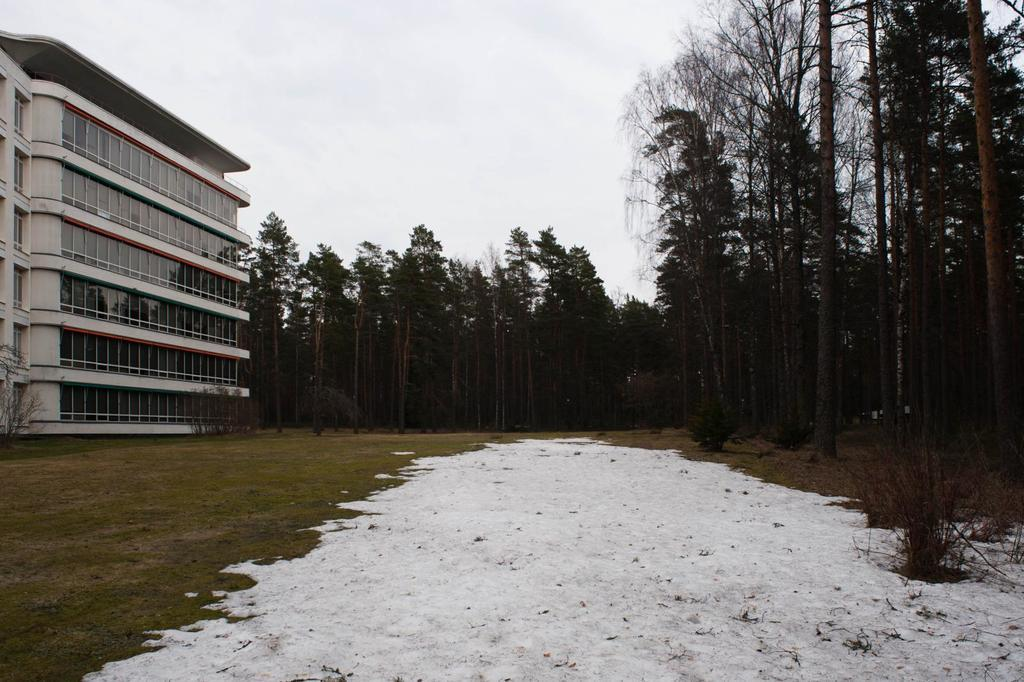What structure is located on the left side of the image? There is a building on the left side of the image. What type of vegetation is on the right side of the image? There are trees on the right side of the image. What is visible in the background of the image? The sky is visible in the background of the image. Can you see a nest in the building in the image? There is no nest visible in the building in the image. Is the father of the person who took the image also present in the image? The image does not provide any information about the person who took the image or their family members, so it is impossible to determine if the father is present. 